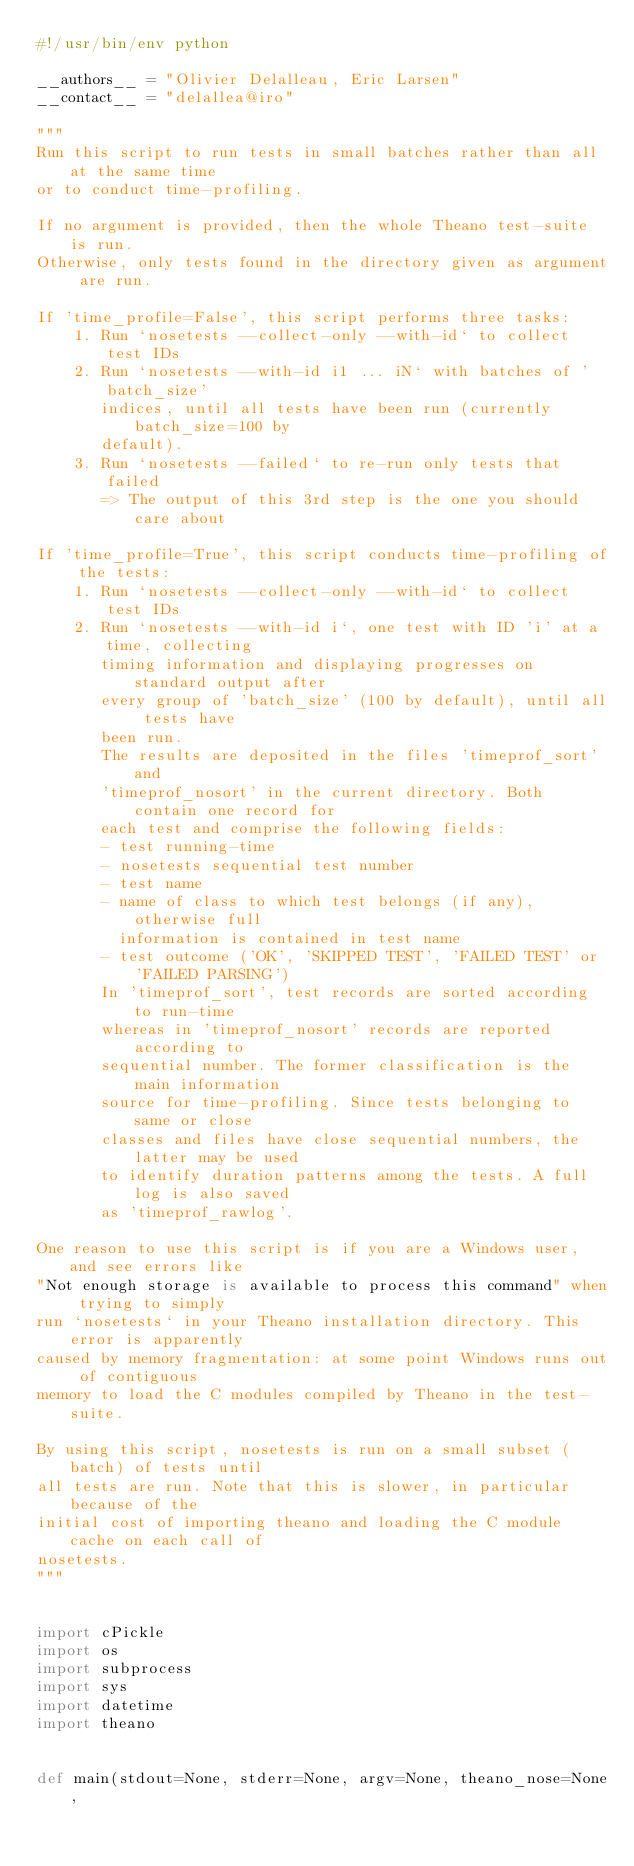Convert code to text. <code><loc_0><loc_0><loc_500><loc_500><_Python_>#!/usr/bin/env python

__authors__ = "Olivier Delalleau, Eric Larsen"
__contact__ = "delallea@iro"

"""
Run this script to run tests in small batches rather than all at the same time
or to conduct time-profiling.

If no argument is provided, then the whole Theano test-suite is run.
Otherwise, only tests found in the directory given as argument are run.

If 'time_profile=False', this script performs three tasks:
    1. Run `nosetests --collect-only --with-id` to collect test IDs
    2. Run `nosetests --with-id i1 ... iN` with batches of 'batch_size'
       indices, until all tests have been run (currently batch_size=100 by
       default).
    3. Run `nosetests --failed` to re-run only tests that failed
       => The output of this 3rd step is the one you should care about

If 'time_profile=True', this script conducts time-profiling of the tests:
    1. Run `nosetests --collect-only --with-id` to collect test IDs
    2. Run `nosetests --with-id i`, one test with ID 'i' at a time, collecting
       timing information and displaying progresses on standard output after
       every group of 'batch_size' (100 by default), until all tests have
       been run.
       The results are deposited in the files 'timeprof_sort' and
       'timeprof_nosort' in the current directory. Both contain one record for
       each test and comprise the following fields:
       - test running-time
       - nosetests sequential test number
       - test name
       - name of class to which test belongs (if any), otherwise full
         information is contained in test name
       - test outcome ('OK', 'SKIPPED TEST', 'FAILED TEST' or 'FAILED PARSING')
       In 'timeprof_sort', test records are sorted according to run-time
       whereas in 'timeprof_nosort' records are reported according to
       sequential number. The former classification is the main information
       source for time-profiling. Since tests belonging to same or close
       classes and files have close sequential numbers, the latter may be used
       to identify duration patterns among the tests. A full log is also saved
       as 'timeprof_rawlog'.

One reason to use this script is if you are a Windows user, and see errors like
"Not enough storage is available to process this command" when trying to simply
run `nosetests` in your Theano installation directory. This error is apparently
caused by memory fragmentation: at some point Windows runs out of contiguous
memory to load the C modules compiled by Theano in the test-suite.

By using this script, nosetests is run on a small subset (batch) of tests until
all tests are run. Note that this is slower, in particular because of the
initial cost of importing theano and loading the C module cache on each call of
nosetests.
"""


import cPickle
import os
import subprocess
import sys
import datetime
import theano


def main(stdout=None, stderr=None, argv=None, theano_nose=None,</code> 